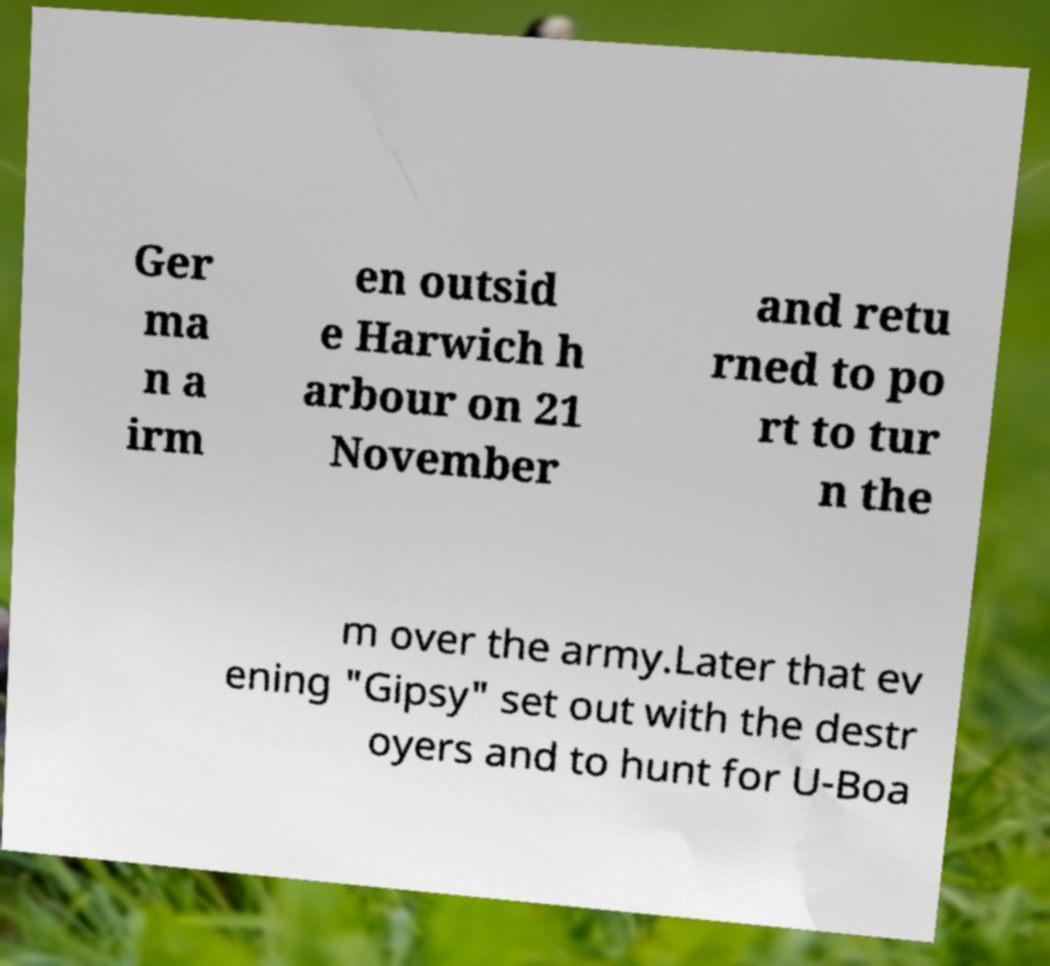I need the written content from this picture converted into text. Can you do that? Ger ma n a irm en outsid e Harwich h arbour on 21 November and retu rned to po rt to tur n the m over the army.Later that ev ening "Gipsy" set out with the destr oyers and to hunt for U-Boa 